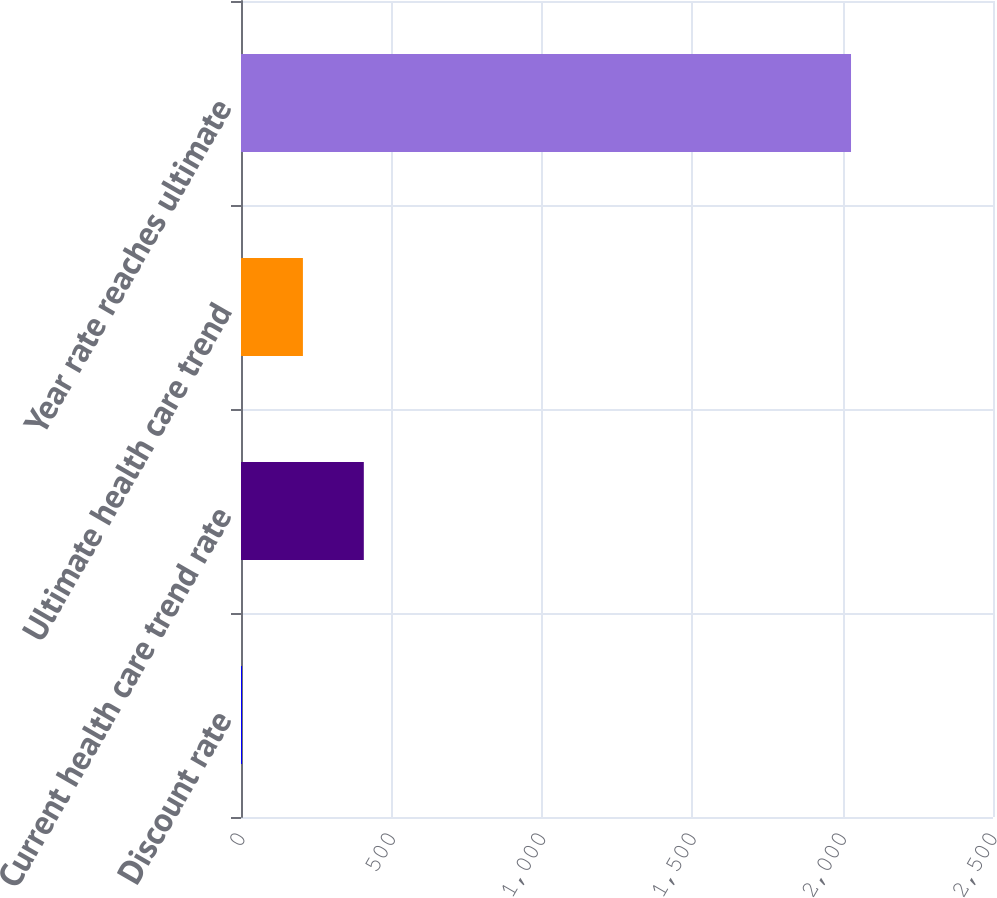Convert chart to OTSL. <chart><loc_0><loc_0><loc_500><loc_500><bar_chart><fcel>Discount rate<fcel>Current health care trend rate<fcel>Ultimate health care trend<fcel>Year rate reaches ultimate<nl><fcel>3.35<fcel>408.29<fcel>205.82<fcel>2028<nl></chart> 